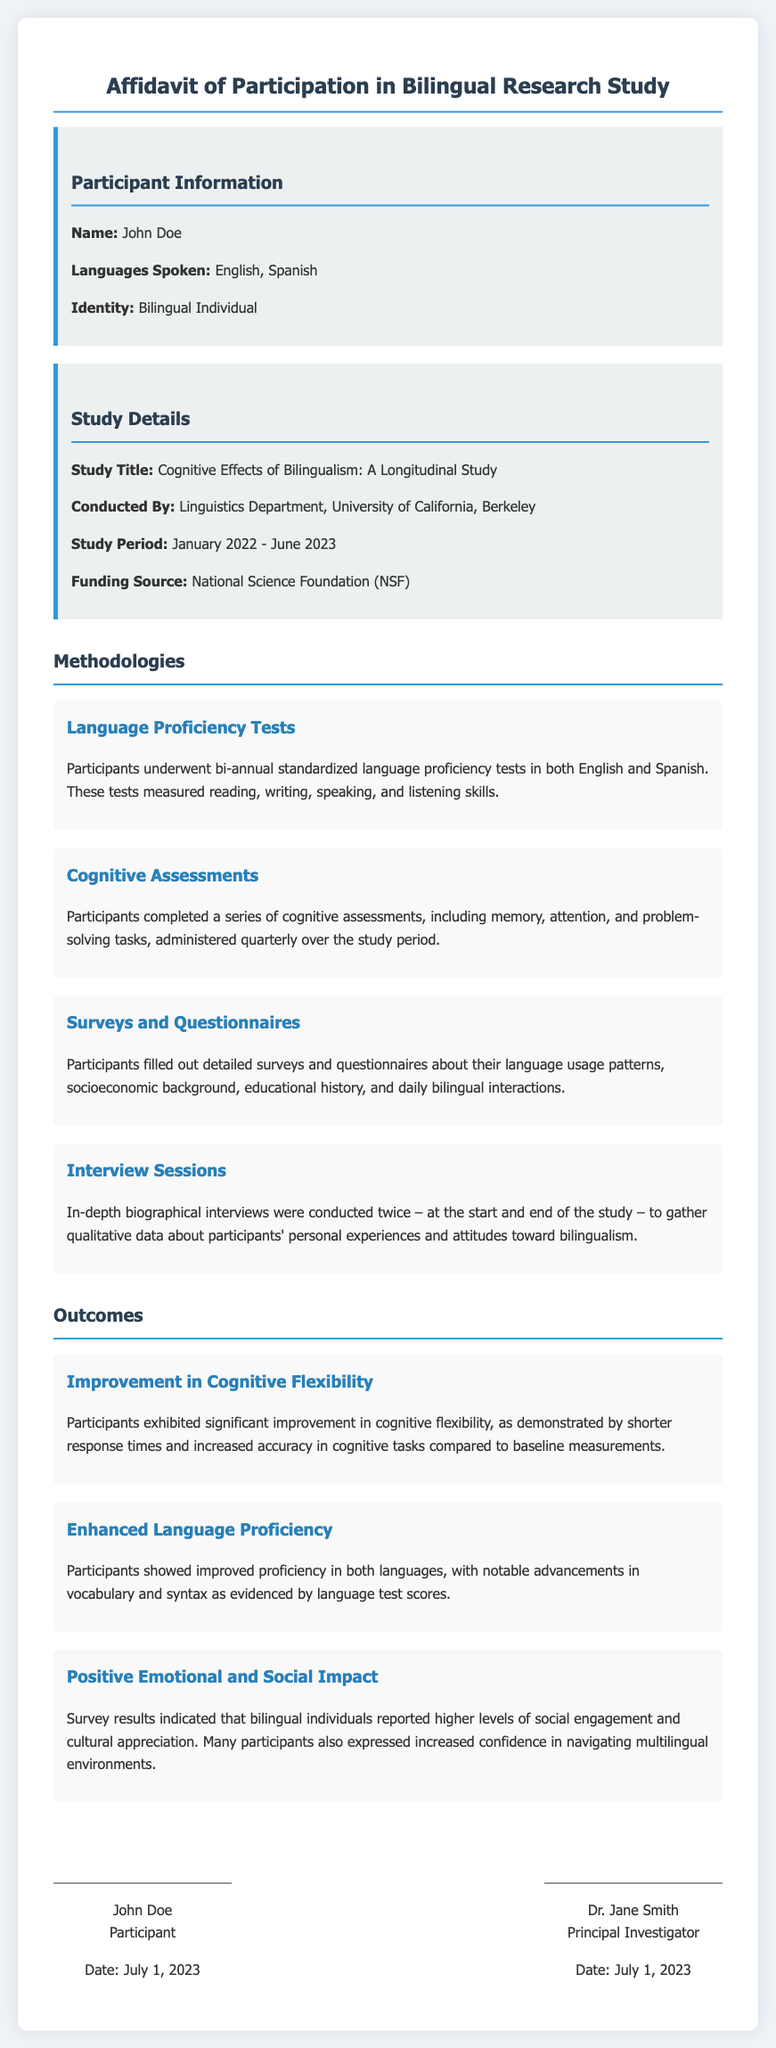What is the participant's name? The participant's name is indicated in the document under Participant Information.
Answer: John Doe What languages does the participant speak? The languages spoken by the participant are listed in the Participant Information section.
Answer: English, Spanish What is the title of the study? The title of the study is provided in the Study Details section.
Answer: Cognitive Effects of Bilingualism: A Longitudinal Study When did the study period begin? The start date of the study period is stated in the Study Details section.
Answer: January 2022 What was measured in the Language Proficiency Tests? The methodology describes what was measured in the tests, focusing on various language skills.
Answer: Reading, writing, speaking, and listening skills What improvement was noted in cognitive flexibility? The outcome section mentions changes seen in cognitive flexibility, drawing from quantitative data.
Answer: Significant improvement What type of assessments were administered quarterly? The document outlines assessments that occurred quarterly under the methodology section.
Answer: Cognitive assessments How often were interviews conducted? The methodology indicates the frequency of interviews throughout the study.
Answer: Twice What funding source supported the study? The funding source is mentioned in the Study Details section.
Answer: National Science Foundation (NSF) What date is mentioned in the signature section? The date is provided next to the signatures of participants and the principal investigator.
Answer: July 1, 2023 